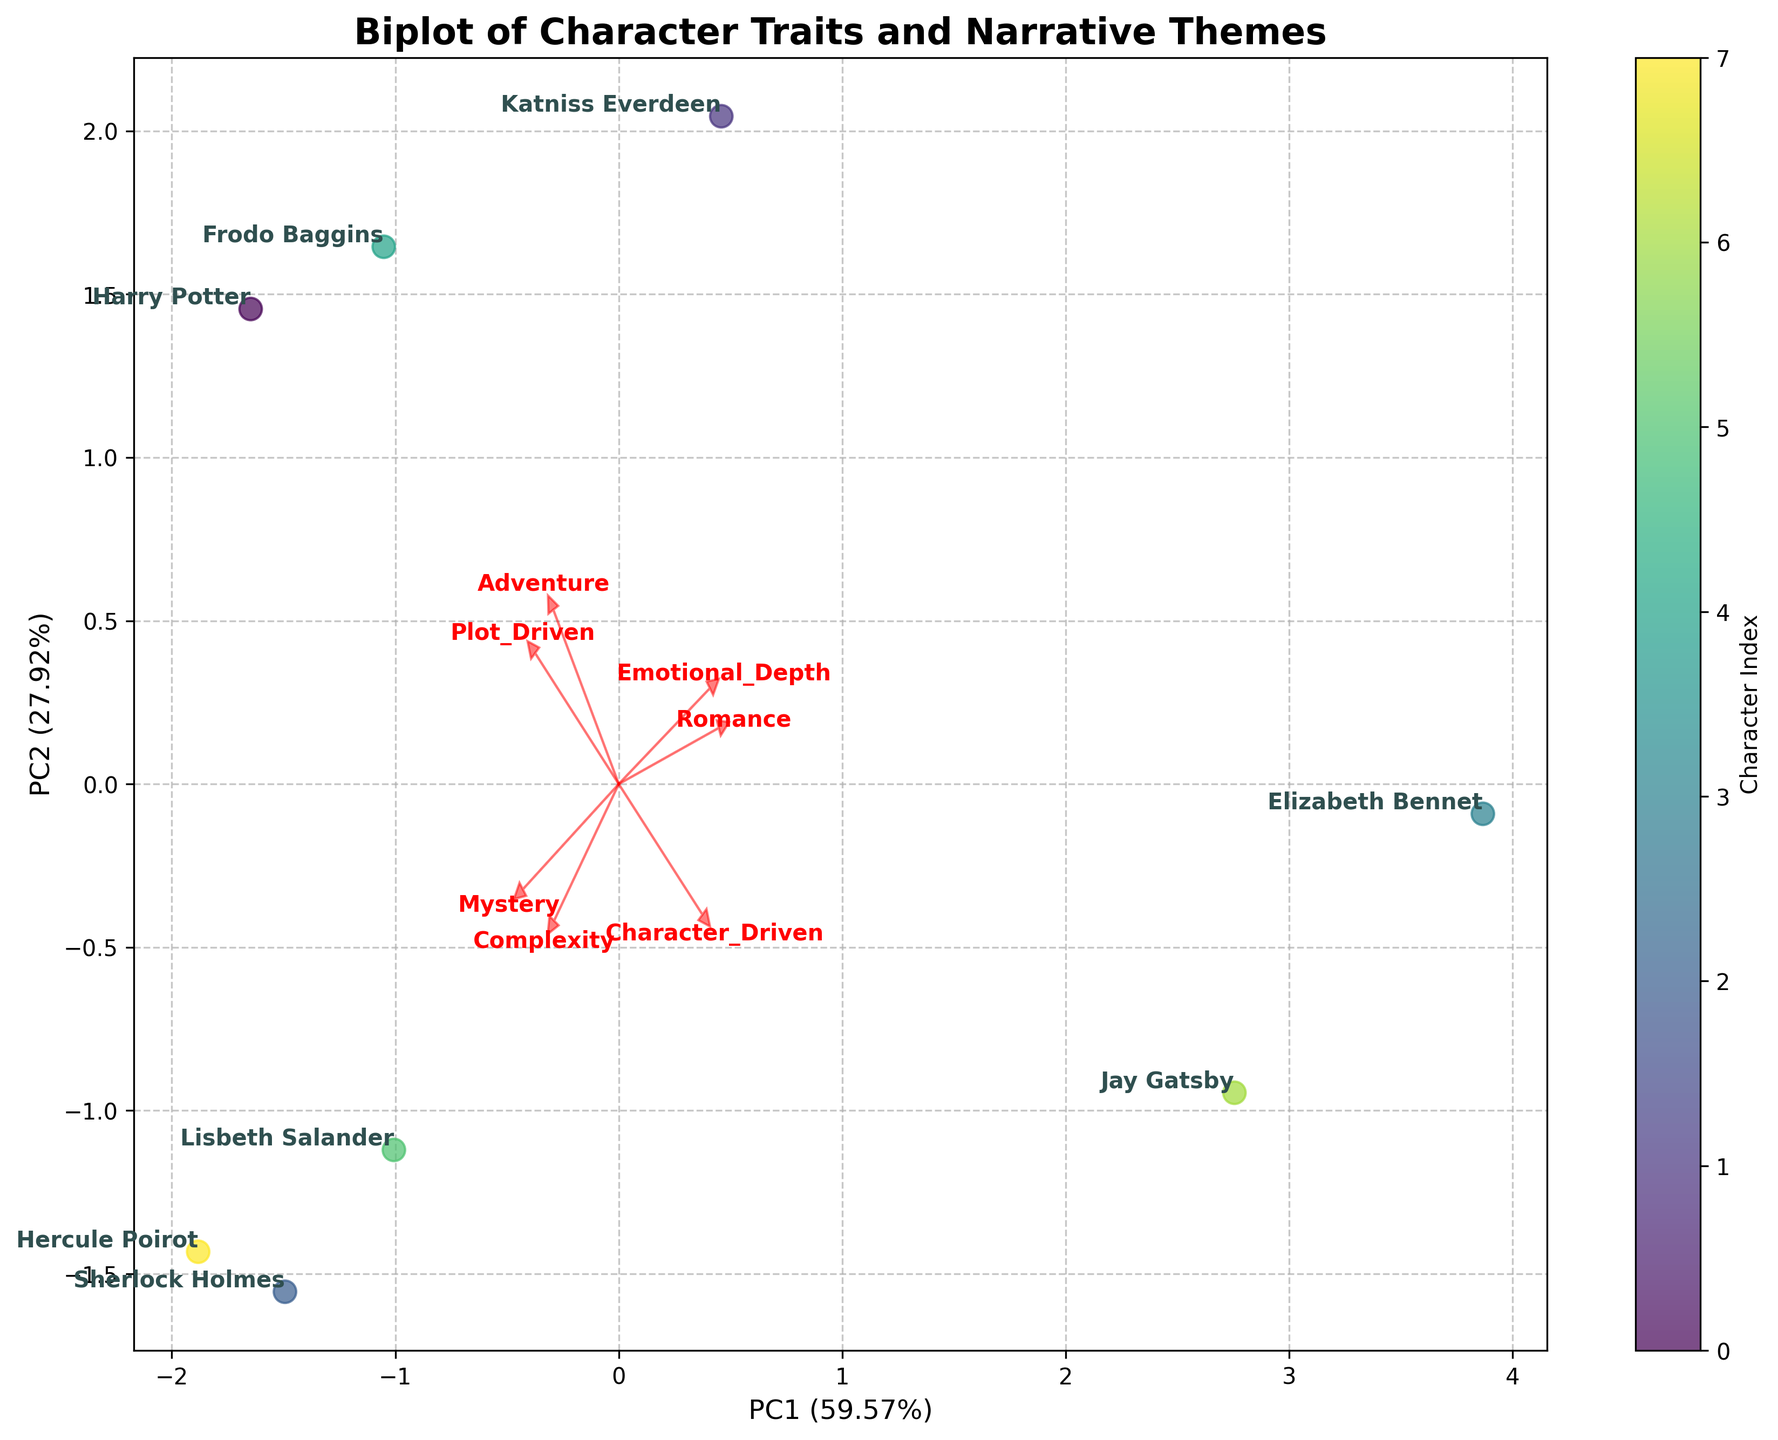What is the title of the plot? The title can be found at the top of the figure, which provides a summary of what the plot is about.
Answer: Biplot of Character Traits and Narrative Themes How many characters are being analyzed in the biplot? Count the total number of labeled data points (character names) visible in the figure.
Answer: 8 Which axis represents the first principal component (PC1), and what is its explained variance percentage? The x-axis label displays which principal component it represents and its explained variance percentage.
Answer: PC1 (variance not specified in the prompt) Which character has the highest value on the PC2 axis? Identify the character with the highest data point along the y-axis.
Answer: Jay Gatsby Comparing Harry Potter and Frodo Baggins, which character is more associated with adventure? Examine the direction and length of the Adventure feature vector and see which character lies closer in that direction.
Answer: Frodo Baggins Which two characters are closest to each other in the plot? Look for the pair of characters with data points that are positioned nearest to each other on the biplot.
Answer: Katniss Everdeen and Frodo Baggins What feature is represented by the arrow pointing closest to Harry Potter? Find the feature vector (arrow) that points closest to the location of Harry Potter.
Answer: Plot_Driven Is Sherlock Holmes more complex or more emotionally deep, according to the plot? Compare the locations relative to the vectors representing Complexity and Emotional_Depth. The length and direction of the arrows signify Sherlock Holmes' relative position.
Answer: More complex How many features have vectors pointing in the positive direction of both PC1 and PC2? Count the number of arrows (feature vectors) that point into the first quadrant of the plot, which corresponds to the positive directions of both axes.
Answer: 3 (Complexity, Plot_Driven, Adventure) Which feature seems to have the least influence on PC1? The feature with the shortest vector length along the PC1 axis has the least influence.
Answer: Romance 